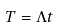<formula> <loc_0><loc_0><loc_500><loc_500>T = \Lambda t</formula> 